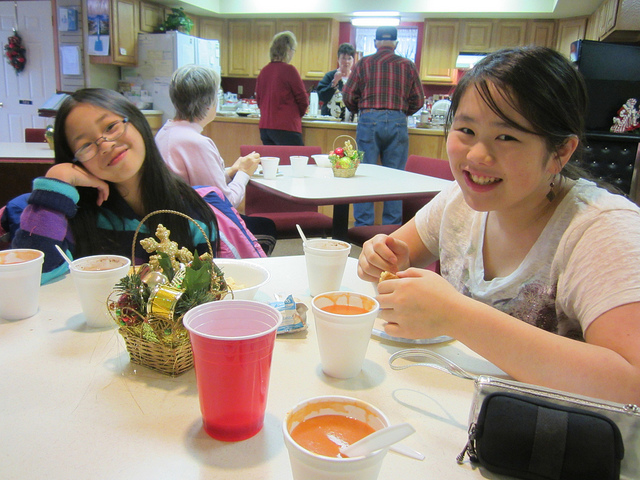<image>Where are the polka dots? There are no polka dots in the image. But it could be on the shirt or the chair. Where are the polka dots? There are no polka dots in the image. 